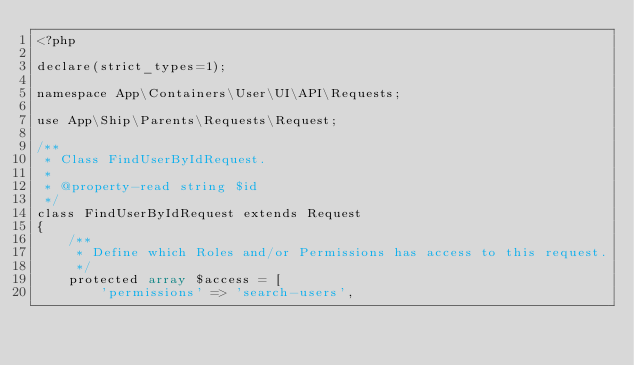Convert code to text. <code><loc_0><loc_0><loc_500><loc_500><_PHP_><?php

declare(strict_types=1);

namespace App\Containers\User\UI\API\Requests;

use App\Ship\Parents\Requests\Request;

/**
 * Class FindUserByIdRequest.
 *
 * @property-read string $id
 */
class FindUserByIdRequest extends Request
{
    /**
     * Define which Roles and/or Permissions has access to this request.
     */
    protected array $access = [
        'permissions' => 'search-users',</code> 